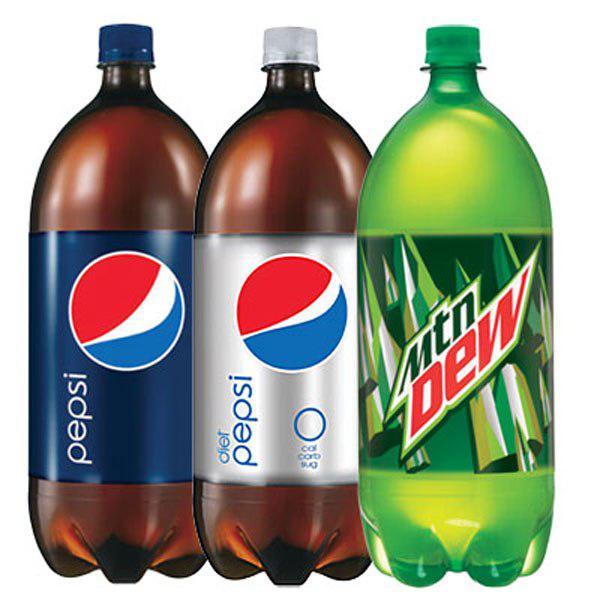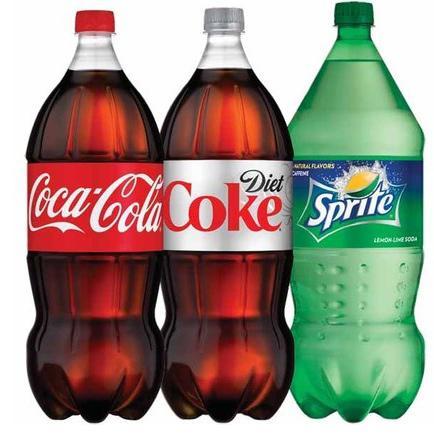The first image is the image on the left, the second image is the image on the right. Assess this claim about the two images: "There are five soda bottles in total.". Correct or not? Answer yes or no. No. The first image is the image on the left, the second image is the image on the right. Given the left and right images, does the statement "The left image contains two non-overlapping bottles, and the right image contains three non-overlapping bottles." hold true? Answer yes or no. No. 